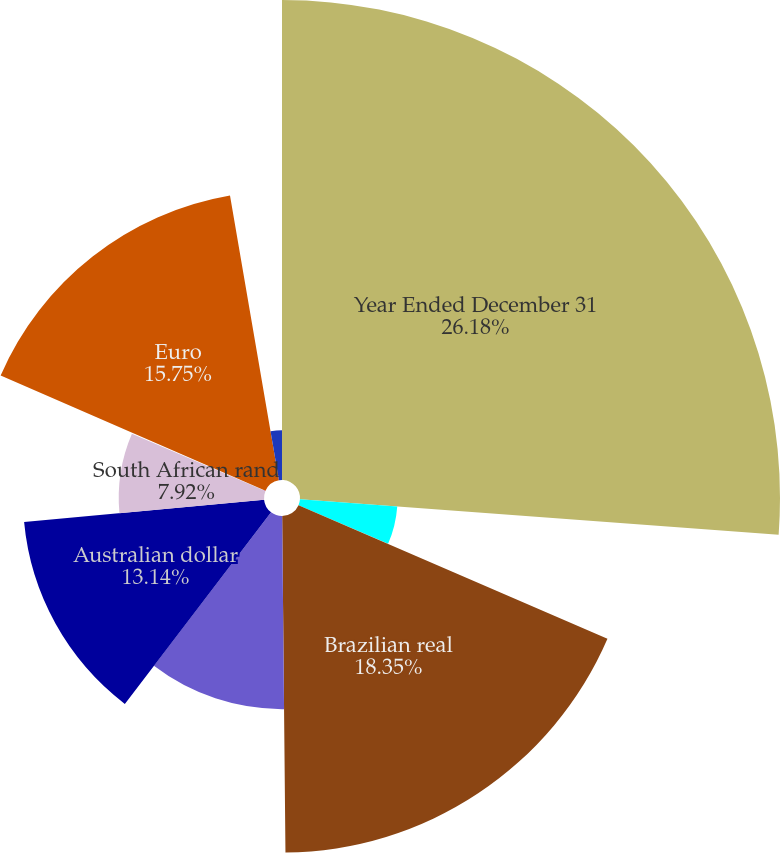Convert chart. <chart><loc_0><loc_0><loc_500><loc_500><pie_chart><fcel>Year Ended December 31<fcel>All operating currencies<fcel>Brazilian real<fcel>Mexican peso<fcel>Australian dollar<fcel>South African rand<fcel>British pound<fcel>Euro<fcel>Japanese yen<nl><fcel>26.17%<fcel>5.32%<fcel>18.35%<fcel>10.53%<fcel>13.14%<fcel>7.92%<fcel>0.1%<fcel>15.75%<fcel>2.71%<nl></chart> 